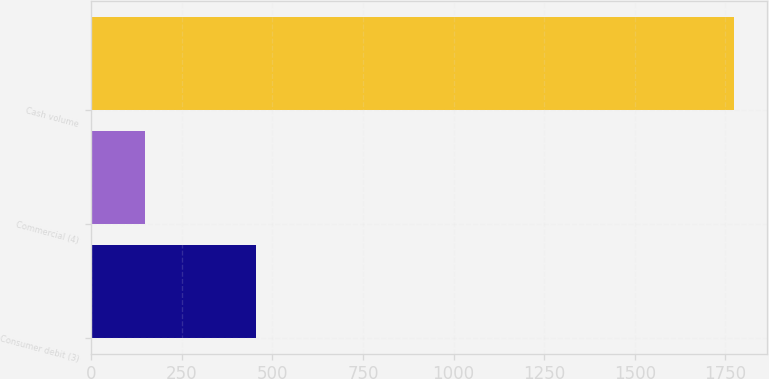Convert chart. <chart><loc_0><loc_0><loc_500><loc_500><bar_chart><fcel>Consumer debit (3)<fcel>Commercial (4)<fcel>Cash volume<nl><fcel>454<fcel>147<fcel>1775<nl></chart> 